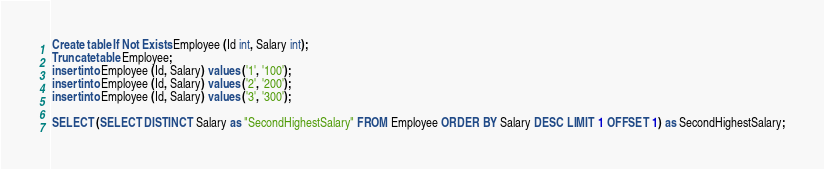<code> <loc_0><loc_0><loc_500><loc_500><_SQL_>Create table If Not Exists Employee (Id int, Salary int);
Truncate table Employee;
insert into Employee (Id, Salary) values ('1', '100');
insert into Employee (Id, Salary) values ('2', '200');
insert into Employee (Id, Salary) values ('3', '300');

SELECT (SELECT DISTINCT Salary as "SecondHighestSalary" FROM Employee ORDER BY Salary DESC LIMIT 1 OFFSET 1) as SecondHighestSalary;</code> 